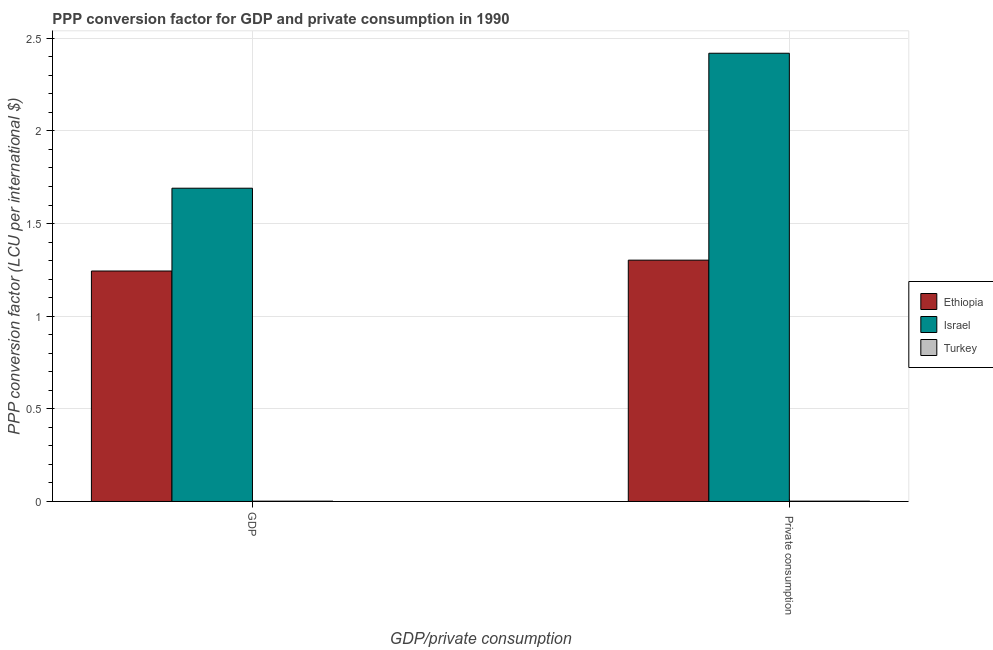How many different coloured bars are there?
Offer a very short reply. 3. Are the number of bars on each tick of the X-axis equal?
Provide a succinct answer. Yes. What is the label of the 2nd group of bars from the left?
Your response must be concise.  Private consumption. What is the ppp conversion factor for private consumption in Israel?
Your answer should be compact. 2.42. Across all countries, what is the maximum ppp conversion factor for private consumption?
Your answer should be compact. 2.42. Across all countries, what is the minimum ppp conversion factor for gdp?
Provide a succinct answer. 0. In which country was the ppp conversion factor for gdp maximum?
Offer a terse response. Israel. What is the total ppp conversion factor for gdp in the graph?
Make the answer very short. 2.94. What is the difference between the ppp conversion factor for gdp in Ethiopia and that in Israel?
Keep it short and to the point. -0.45. What is the difference between the ppp conversion factor for gdp in Israel and the ppp conversion factor for private consumption in Ethiopia?
Offer a very short reply. 0.39. What is the average ppp conversion factor for gdp per country?
Your response must be concise. 0.98. What is the difference between the ppp conversion factor for private consumption and ppp conversion factor for gdp in Israel?
Keep it short and to the point. 0.73. In how many countries, is the ppp conversion factor for gdp greater than 1.7 LCU?
Give a very brief answer. 0. What is the ratio of the ppp conversion factor for gdp in Israel to that in Turkey?
Your response must be concise. 1032.12. Is the ppp conversion factor for gdp in Israel less than that in Turkey?
Give a very brief answer. No. Are all the bars in the graph horizontal?
Provide a short and direct response. No. How many countries are there in the graph?
Offer a terse response. 3. How many legend labels are there?
Make the answer very short. 3. How are the legend labels stacked?
Your answer should be very brief. Vertical. What is the title of the graph?
Give a very brief answer. PPP conversion factor for GDP and private consumption in 1990. What is the label or title of the X-axis?
Make the answer very short. GDP/private consumption. What is the label or title of the Y-axis?
Your answer should be compact. PPP conversion factor (LCU per international $). What is the PPP conversion factor (LCU per international $) in Ethiopia in GDP?
Provide a short and direct response. 1.24. What is the PPP conversion factor (LCU per international $) in Israel in GDP?
Your response must be concise. 1.69. What is the PPP conversion factor (LCU per international $) of Turkey in GDP?
Provide a succinct answer. 0. What is the PPP conversion factor (LCU per international $) in Ethiopia in  Private consumption?
Keep it short and to the point. 1.3. What is the PPP conversion factor (LCU per international $) in Israel in  Private consumption?
Offer a very short reply. 2.42. What is the PPP conversion factor (LCU per international $) of Turkey in  Private consumption?
Offer a terse response. 0. Across all GDP/private consumption, what is the maximum PPP conversion factor (LCU per international $) in Ethiopia?
Provide a short and direct response. 1.3. Across all GDP/private consumption, what is the maximum PPP conversion factor (LCU per international $) in Israel?
Offer a very short reply. 2.42. Across all GDP/private consumption, what is the maximum PPP conversion factor (LCU per international $) in Turkey?
Your answer should be very brief. 0. Across all GDP/private consumption, what is the minimum PPP conversion factor (LCU per international $) in Ethiopia?
Ensure brevity in your answer.  1.24. Across all GDP/private consumption, what is the minimum PPP conversion factor (LCU per international $) of Israel?
Make the answer very short. 1.69. Across all GDP/private consumption, what is the minimum PPP conversion factor (LCU per international $) in Turkey?
Offer a very short reply. 0. What is the total PPP conversion factor (LCU per international $) of Ethiopia in the graph?
Ensure brevity in your answer.  2.55. What is the total PPP conversion factor (LCU per international $) in Israel in the graph?
Give a very brief answer. 4.11. What is the total PPP conversion factor (LCU per international $) in Turkey in the graph?
Give a very brief answer. 0. What is the difference between the PPP conversion factor (LCU per international $) of Ethiopia in GDP and that in  Private consumption?
Offer a very short reply. -0.06. What is the difference between the PPP conversion factor (LCU per international $) of Israel in GDP and that in  Private consumption?
Provide a succinct answer. -0.73. What is the difference between the PPP conversion factor (LCU per international $) in Turkey in GDP and that in  Private consumption?
Provide a short and direct response. -0. What is the difference between the PPP conversion factor (LCU per international $) in Ethiopia in GDP and the PPP conversion factor (LCU per international $) in Israel in  Private consumption?
Your answer should be compact. -1.18. What is the difference between the PPP conversion factor (LCU per international $) of Ethiopia in GDP and the PPP conversion factor (LCU per international $) of Turkey in  Private consumption?
Your answer should be compact. 1.24. What is the difference between the PPP conversion factor (LCU per international $) in Israel in GDP and the PPP conversion factor (LCU per international $) in Turkey in  Private consumption?
Provide a short and direct response. 1.69. What is the average PPP conversion factor (LCU per international $) in Ethiopia per GDP/private consumption?
Make the answer very short. 1.27. What is the average PPP conversion factor (LCU per international $) in Israel per GDP/private consumption?
Provide a short and direct response. 2.05. What is the average PPP conversion factor (LCU per international $) in Turkey per GDP/private consumption?
Your response must be concise. 0. What is the difference between the PPP conversion factor (LCU per international $) in Ethiopia and PPP conversion factor (LCU per international $) in Israel in GDP?
Ensure brevity in your answer.  -0.45. What is the difference between the PPP conversion factor (LCU per international $) of Ethiopia and PPP conversion factor (LCU per international $) of Turkey in GDP?
Make the answer very short. 1.24. What is the difference between the PPP conversion factor (LCU per international $) of Israel and PPP conversion factor (LCU per international $) of Turkey in GDP?
Ensure brevity in your answer.  1.69. What is the difference between the PPP conversion factor (LCU per international $) of Ethiopia and PPP conversion factor (LCU per international $) of Israel in  Private consumption?
Give a very brief answer. -1.12. What is the difference between the PPP conversion factor (LCU per international $) in Ethiopia and PPP conversion factor (LCU per international $) in Turkey in  Private consumption?
Your response must be concise. 1.3. What is the difference between the PPP conversion factor (LCU per international $) in Israel and PPP conversion factor (LCU per international $) in Turkey in  Private consumption?
Ensure brevity in your answer.  2.42. What is the ratio of the PPP conversion factor (LCU per international $) of Ethiopia in GDP to that in  Private consumption?
Offer a very short reply. 0.95. What is the ratio of the PPP conversion factor (LCU per international $) in Israel in GDP to that in  Private consumption?
Offer a terse response. 0.7. What is the ratio of the PPP conversion factor (LCU per international $) of Turkey in GDP to that in  Private consumption?
Ensure brevity in your answer.  0.96. What is the difference between the highest and the second highest PPP conversion factor (LCU per international $) of Ethiopia?
Make the answer very short. 0.06. What is the difference between the highest and the second highest PPP conversion factor (LCU per international $) of Israel?
Give a very brief answer. 0.73. What is the difference between the highest and the second highest PPP conversion factor (LCU per international $) in Turkey?
Ensure brevity in your answer.  0. What is the difference between the highest and the lowest PPP conversion factor (LCU per international $) in Ethiopia?
Give a very brief answer. 0.06. What is the difference between the highest and the lowest PPP conversion factor (LCU per international $) of Israel?
Provide a succinct answer. 0.73. 